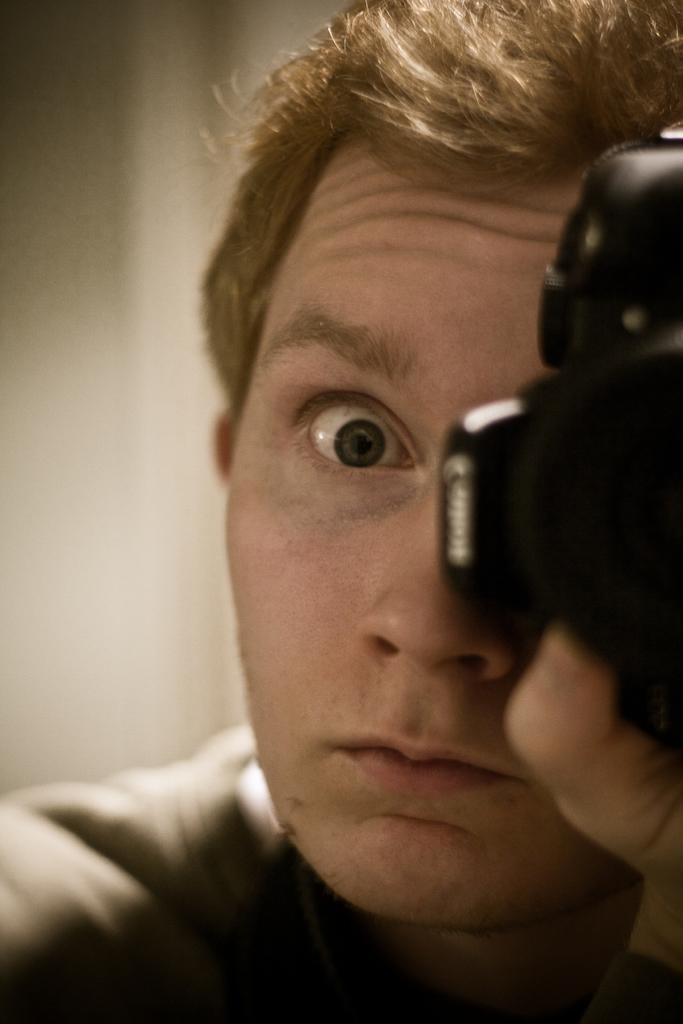What is the person in the image holding? The person is holding a camera in the image. What can be observed about the background of the image? The background of the image is blurred. What type of insurance does the person in the image have for their camera? There is no information about the person's insurance for their camera in the image. 